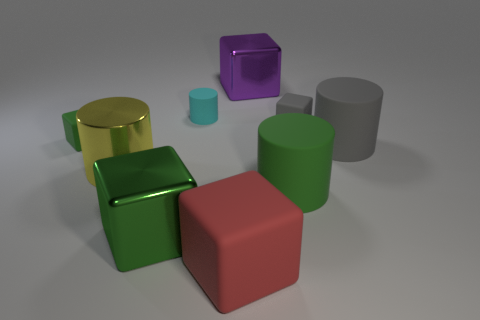Subtract 2 cubes. How many cubes are left? 3 Subtract all small green cubes. How many cubes are left? 4 Subtract all red blocks. How many blocks are left? 4 Subtract all brown cubes. Subtract all purple cylinders. How many cubes are left? 5 Add 1 big shiny cylinders. How many objects exist? 10 Subtract all cylinders. How many objects are left? 5 Add 7 big green blocks. How many big green blocks exist? 8 Subtract 0 brown balls. How many objects are left? 9 Subtract all yellow rubber cylinders. Subtract all red blocks. How many objects are left? 8 Add 9 big purple metallic blocks. How many big purple metallic blocks are left? 10 